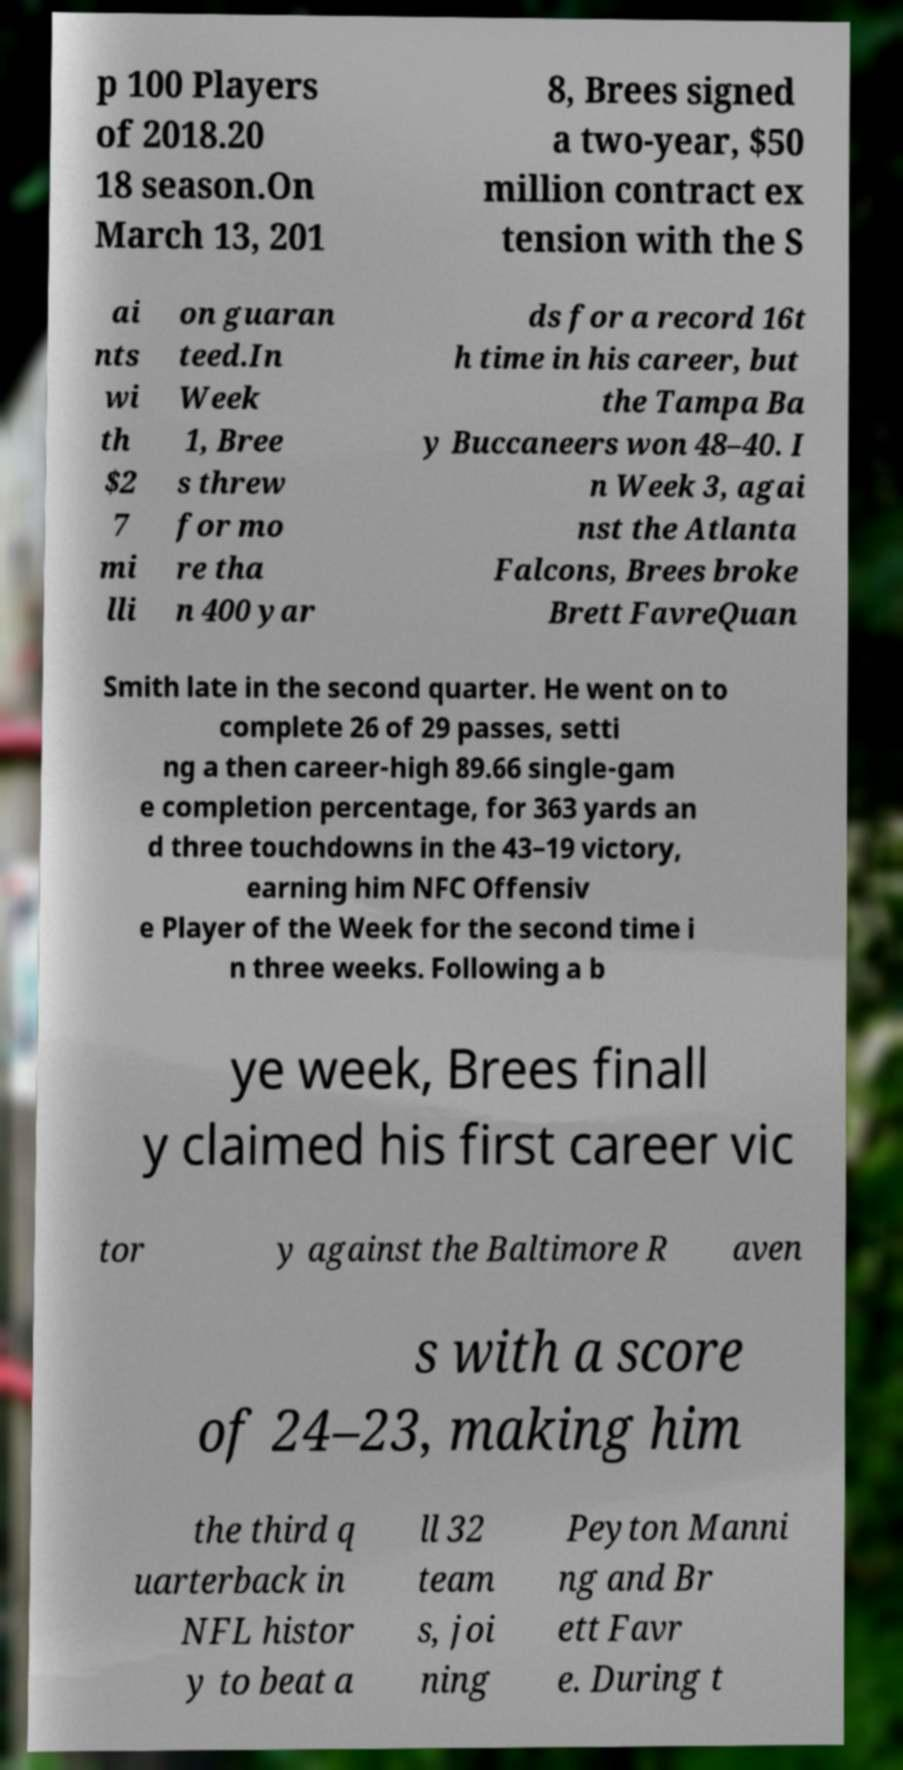Could you assist in decoding the text presented in this image and type it out clearly? p 100 Players of 2018.20 18 season.On March 13, 201 8, Brees signed a two-year, $50 million contract ex tension with the S ai nts wi th $2 7 mi lli on guaran teed.In Week 1, Bree s threw for mo re tha n 400 yar ds for a record 16t h time in his career, but the Tampa Ba y Buccaneers won 48–40. I n Week 3, agai nst the Atlanta Falcons, Brees broke Brett FavreQuan Smith late in the second quarter. He went on to complete 26 of 29 passes, setti ng a then career-high 89.66 single-gam e completion percentage, for 363 yards an d three touchdowns in the 43–19 victory, earning him NFC Offensiv e Player of the Week for the second time i n three weeks. Following a b ye week, Brees finall y claimed his first career vic tor y against the Baltimore R aven s with a score of 24–23, making him the third q uarterback in NFL histor y to beat a ll 32 team s, joi ning Peyton Manni ng and Br ett Favr e. During t 